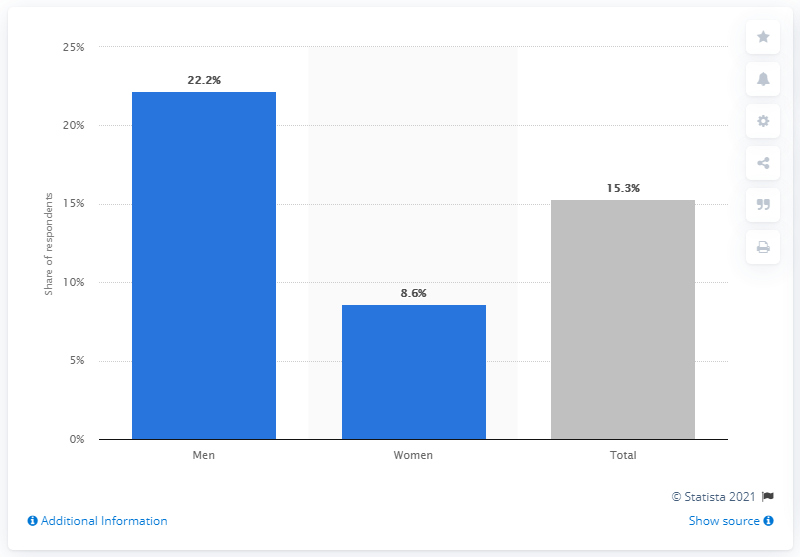What does this graph represent? This graph depicts the share of respondents who searched for sexual partners on the internet, with separate bars representing men, women, and the total. 